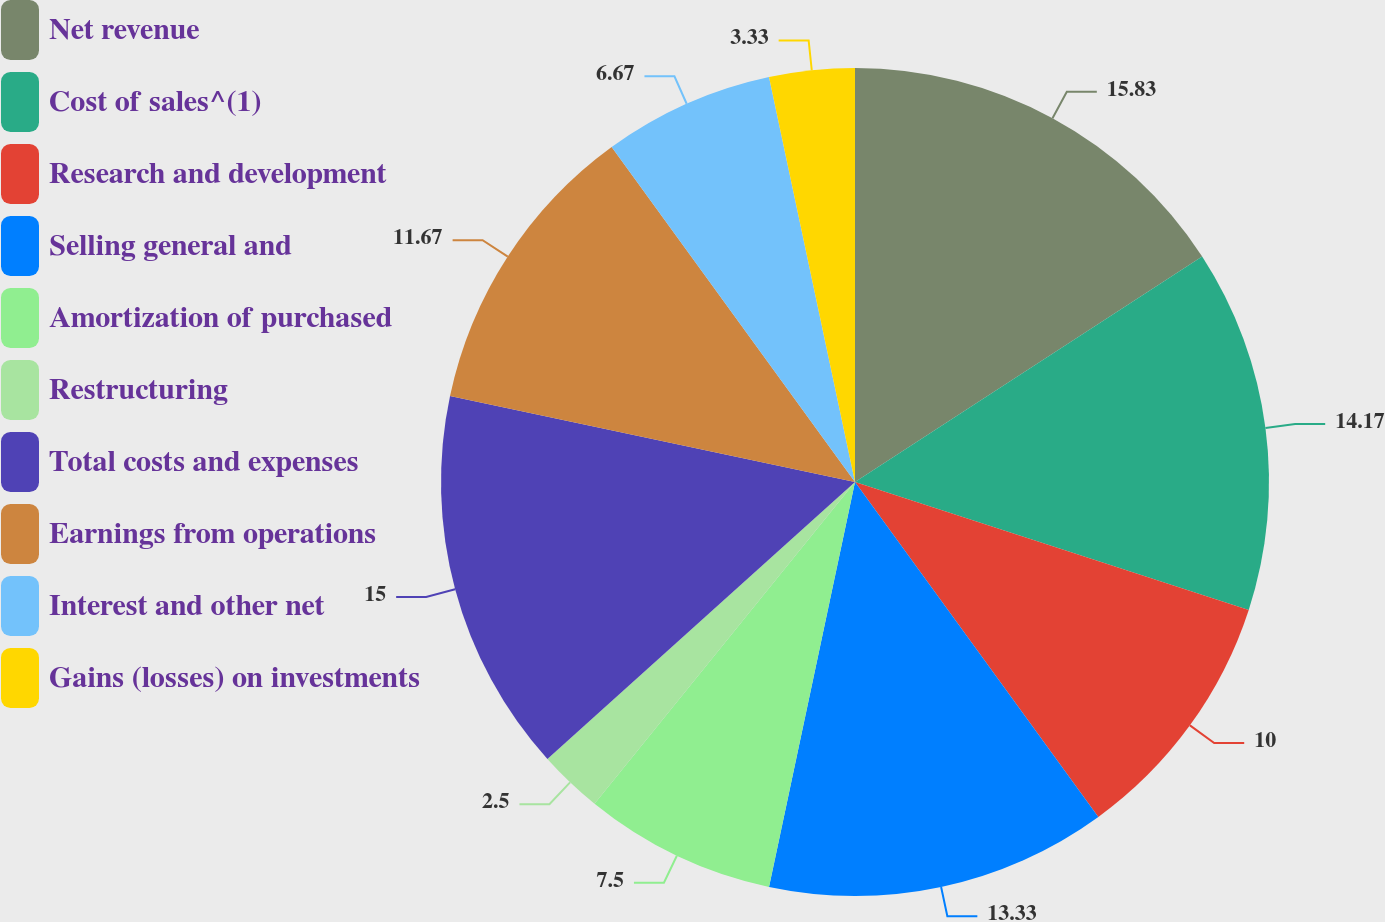Convert chart. <chart><loc_0><loc_0><loc_500><loc_500><pie_chart><fcel>Net revenue<fcel>Cost of sales^(1)<fcel>Research and development<fcel>Selling general and<fcel>Amortization of purchased<fcel>Restructuring<fcel>Total costs and expenses<fcel>Earnings from operations<fcel>Interest and other net<fcel>Gains (losses) on investments<nl><fcel>15.83%<fcel>14.17%<fcel>10.0%<fcel>13.33%<fcel>7.5%<fcel>2.5%<fcel>15.0%<fcel>11.67%<fcel>6.67%<fcel>3.33%<nl></chart> 